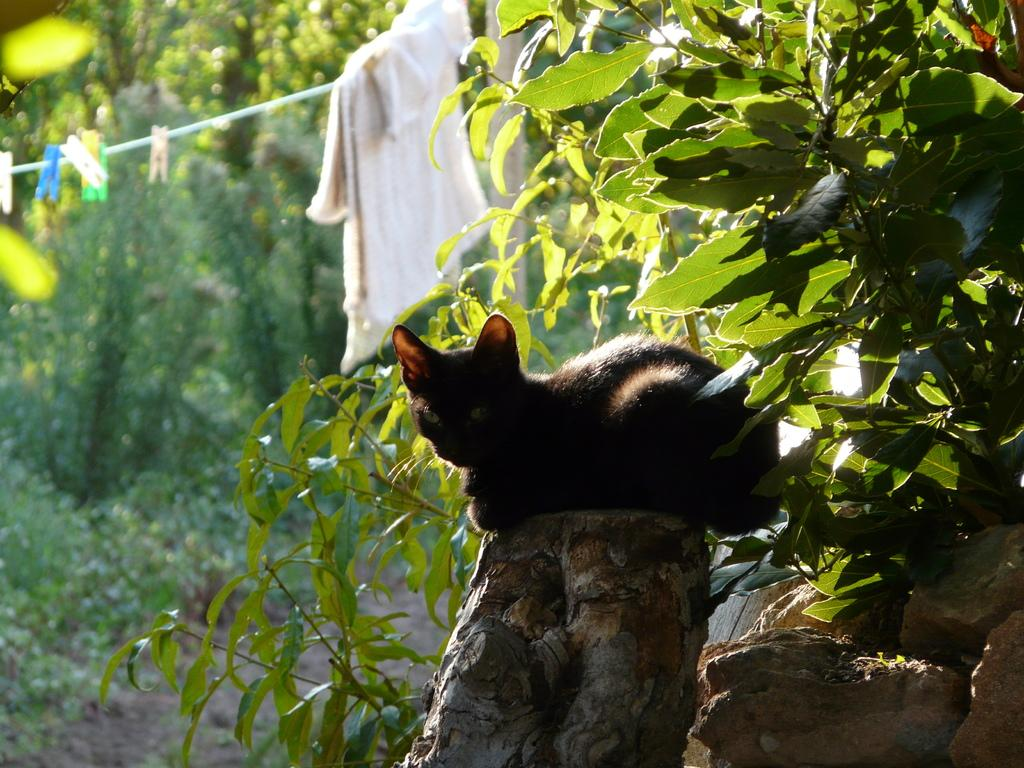What animal is in the middle of the image? There is a black cat in the middle of the image. What is hanging on a rope in the image? There is a cloth hanging on a rope in the image. What can be seen in the background of the image? There are trees in the background of the image. What type of shoes is the cat wearing in the image? Cats do not wear shoes, and there are no shoes visible in the image. 